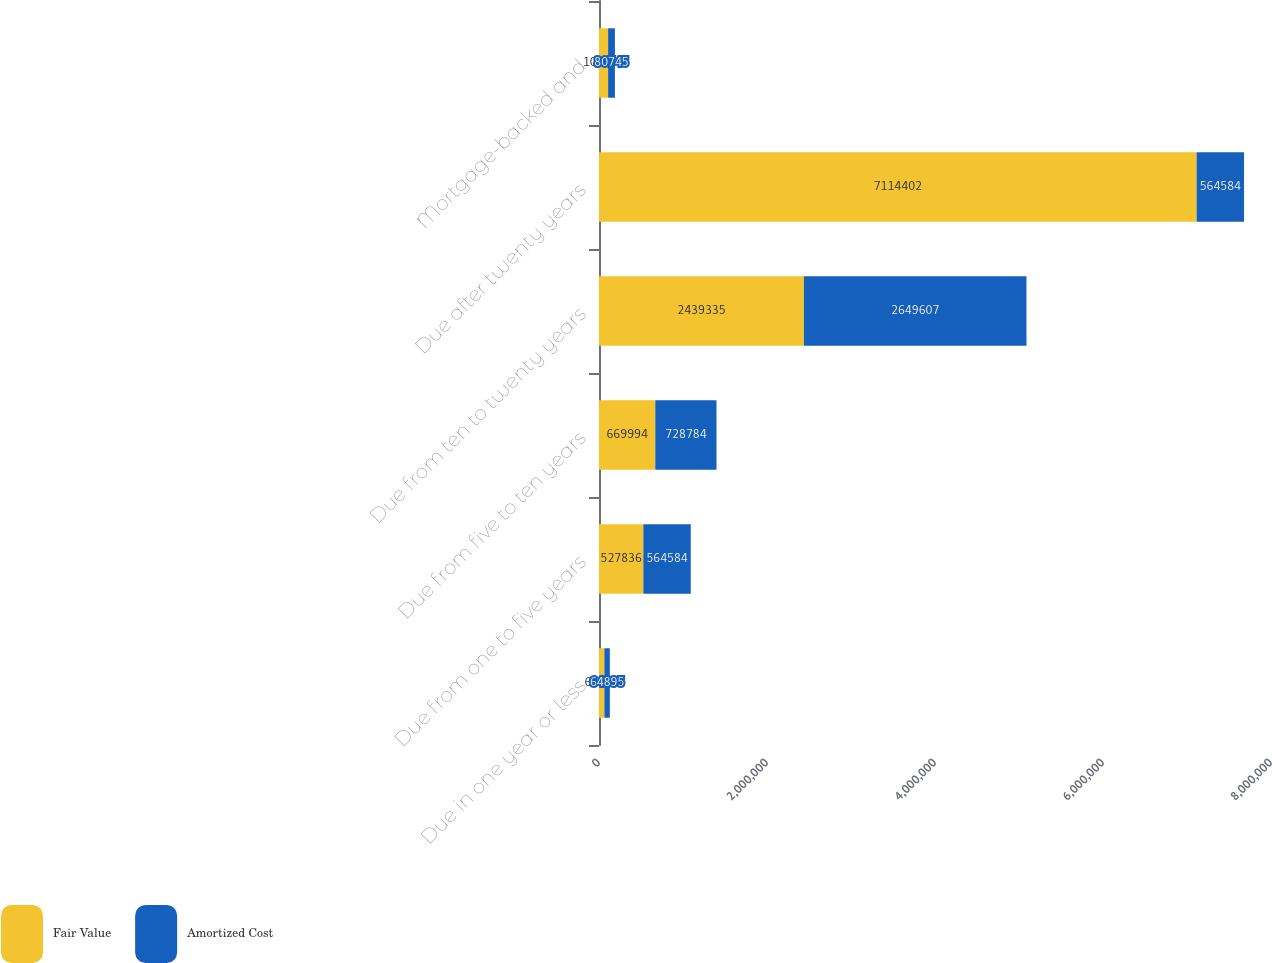<chart> <loc_0><loc_0><loc_500><loc_500><stacked_bar_chart><ecel><fcel>Due in one year or less<fcel>Due from one to five years<fcel>Due from five to ten years<fcel>Due from ten to twenty years<fcel>Due after twenty years<fcel>Mortgage-backed and<nl><fcel>Fair Value<fcel>64222<fcel>527836<fcel>669994<fcel>2.43934e+06<fcel>7.1144e+06<fcel>108455<nl><fcel>Amortized Cost<fcel>64895<fcel>564584<fcel>728784<fcel>2.64961e+06<fcel>564584<fcel>80745<nl></chart> 